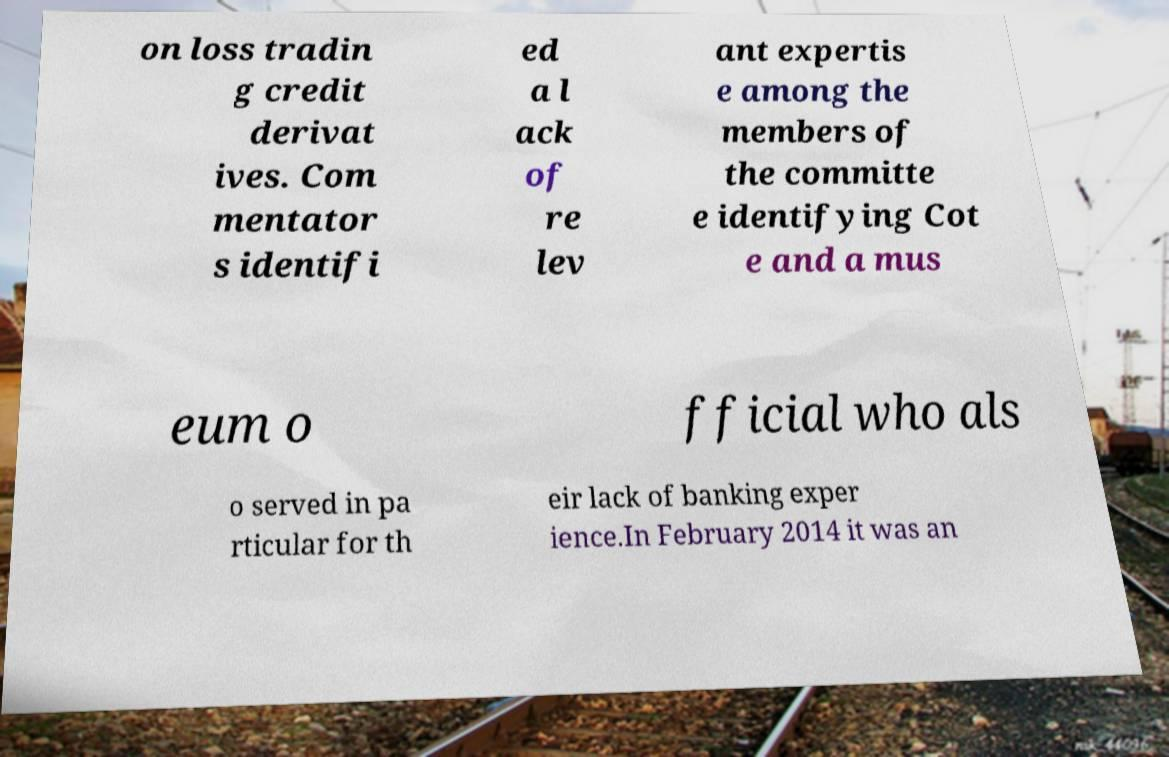For documentation purposes, I need the text within this image transcribed. Could you provide that? on loss tradin g credit derivat ives. Com mentator s identifi ed a l ack of re lev ant expertis e among the members of the committe e identifying Cot e and a mus eum o fficial who als o served in pa rticular for th eir lack of banking exper ience.In February 2014 it was an 